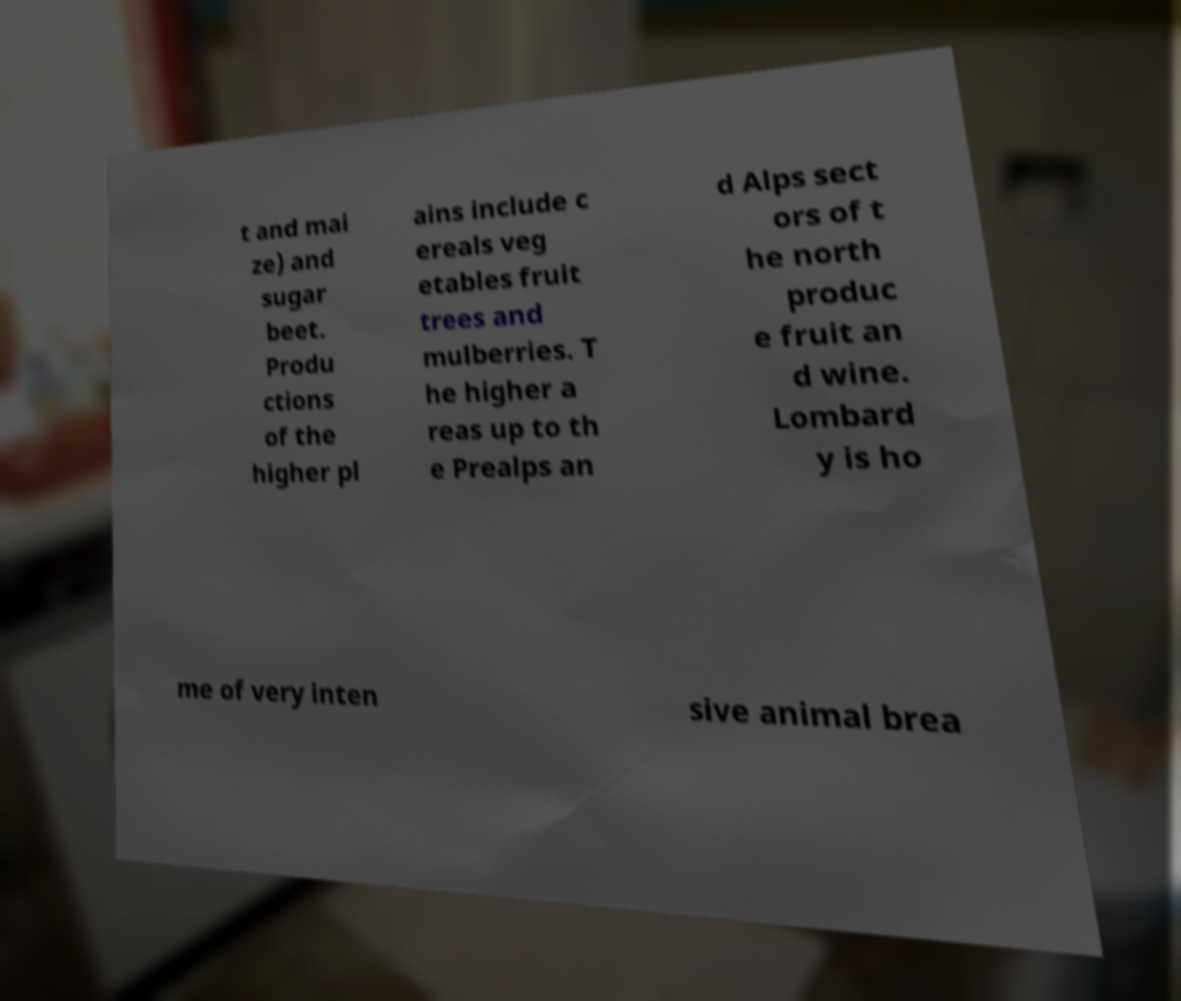Can you accurately transcribe the text from the provided image for me? t and mai ze) and sugar beet. Produ ctions of the higher pl ains include c ereals veg etables fruit trees and mulberries. T he higher a reas up to th e Prealps an d Alps sect ors of t he north produc e fruit an d wine. Lombard y is ho me of very inten sive animal brea 